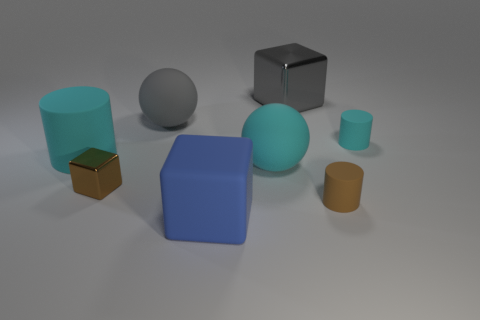Can you tell me what the surfaces of these objects feel like? The surfaces of these objects vary; the metallic ones would feel cool and smooth, while the matte colored objects might have a more plastic or rubbery texture, offering a slight resistance to the touch. 